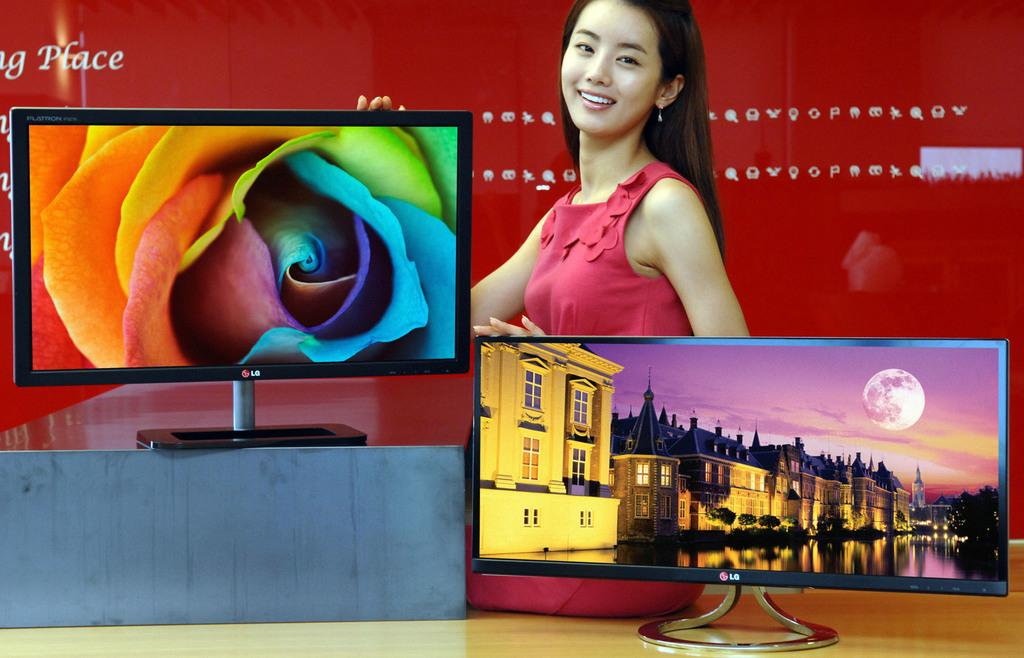Provide a one-sentence caption for the provided image. a pair of LG televisions being shown off by a woman in a red dress. 